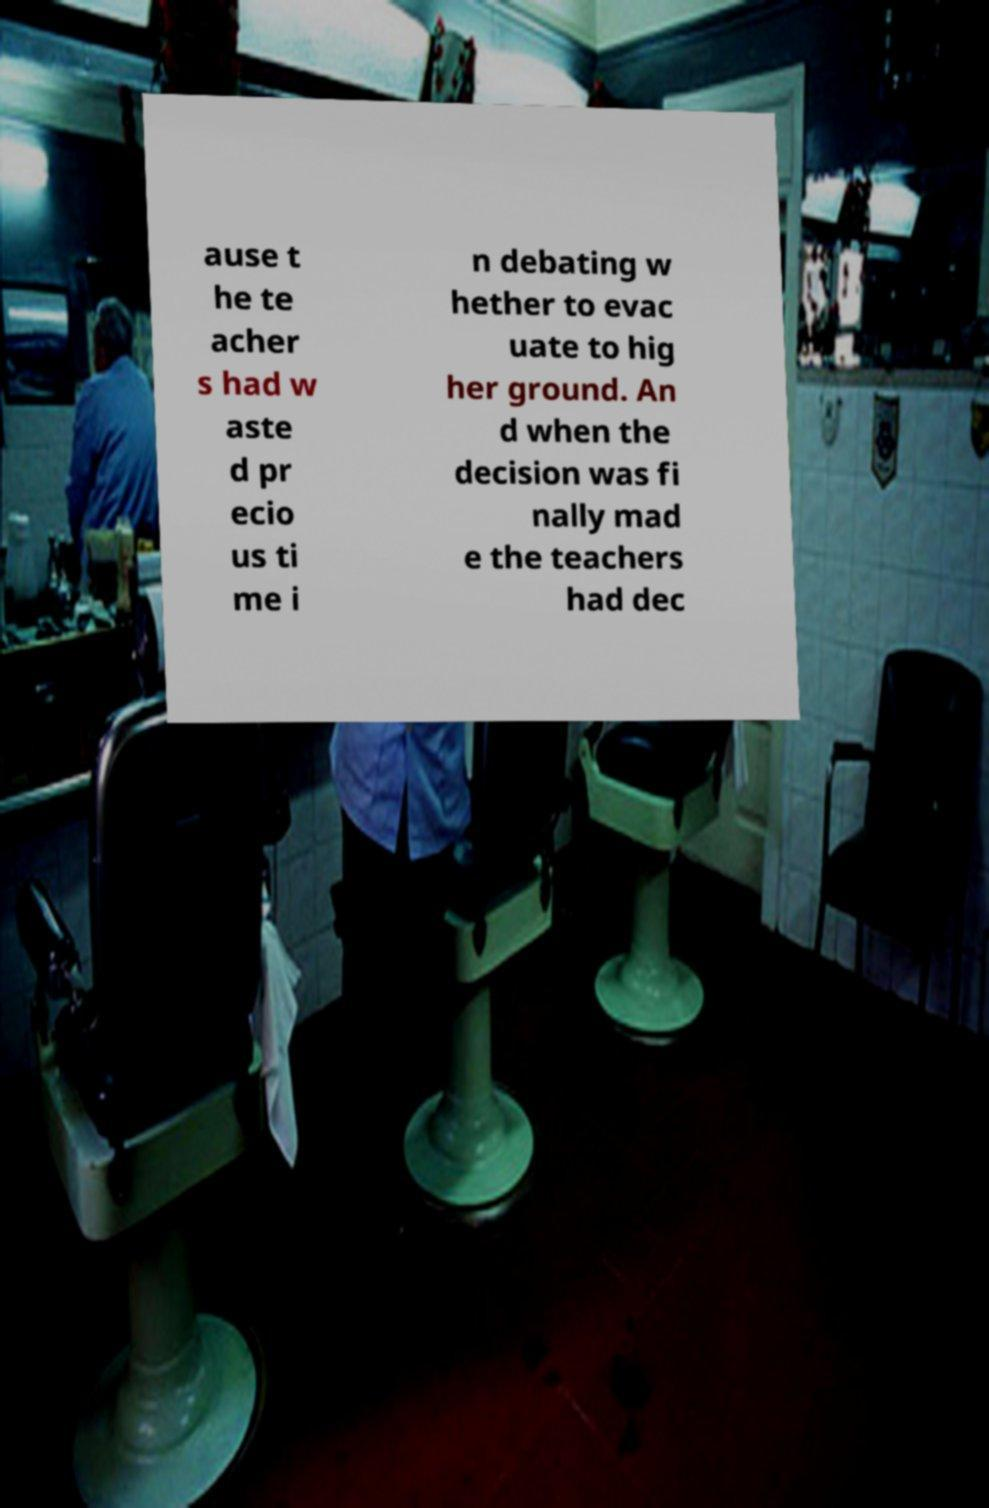For documentation purposes, I need the text within this image transcribed. Could you provide that? ause t he te acher s had w aste d pr ecio us ti me i n debating w hether to evac uate to hig her ground. An d when the decision was fi nally mad e the teachers had dec 